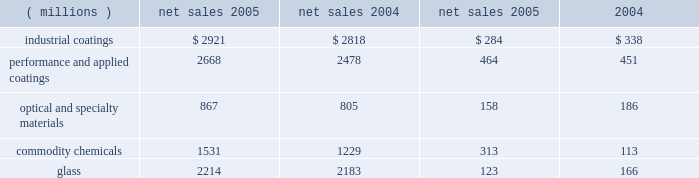Management 2019s discussion and analysis of increased volumes in our performance and applied coatings , optical and specialty materials and glass reportable business segments was offset by volume declines in the commodity chemicals reportable business segment .
The volume decline in the commodity chemicals reportable business segment was due in part to lost sales resulting from the impact of hurricane rita , as discussed below .
Cost of sales as a percentage of sales increased to 63.5% ( 63.5 % ) as compared to 63.1% ( 63.1 % ) in 2004 .
Inflation , including higher coatings raw material costs and higher energy costs in our commodity chemicals and glass reportable business segments increased our cost of sales .
Selling , general and administrative expense declined slightly as a percentage of sales to 17.4% ( 17.4 % ) despite increasing by $ 56 million in 2005 .
These costs increased primarily due to increased advertising in our optical products operating segment and higher expenses due to store expansions in our architectural coatings operating segment .
Interest expense declined $ 9 million in 2005 , reflecting the year over year reduction in the outstanding debt balance of $ 80 million .
Other charges increased $ 284 million in 2005 primarily due to pretax charges of $ 132 million related to the marvin legal settlement , net of $ 18 million in insurance recoveries , $ 61 million for the federal glass class action antitrust legal settlement , $ 34 million of direct costs related to the impact of hurricanes rita and katrina , $ 27 million for an asset impairment charge in our fine chemicals operating segment , $ 19 million for debt refinancing costs and an increase of $ 12 million for environmental remediation costs .
Net income and earnings per share 2013 assuming dilution for 2005 were $ 596 million and $ 3.49 respectively , compared to $ 683 million and $ 3.95 , respectively , for 2004 .
Net income in 2005 included aftertax charges of $ 117 million , or 68 cents a share , for legal settlements net of insurance ; $ 21 million , or 12 cents a share for direct costs related to the impact of hurricanes katrina and rita ; $ 17 million , or 10 cents a share related to an asset impairment charge related to our fine chemicals business ; and $ 12 million , or 7 cents a share , for debt refinancing costs .
The legal settlements net of insurance include aftertax charges of $ 80 million for the marvin legal settlement , net of insurance recoveries , and $ 37 million for the impact of the federal glass class action antitrust legal settlement .
Net income for 2005 and 2004 included an aftertax charge of $ 13 million , or 8 cents a share , and $ 19 million , or 11 cents a share , respectively , to reflect the net increase in the current value of the company 2019s obligation relating to asbestos claims under the ppg settlement arrangement .
Results of reportable business segments net sales segment income ( millions ) 2005 2004 2005 2004 industrial coatings $ 2921 $ 2818 $ 284 $ 338 performance and applied coatings 2668 2478 464 451 optical and specialty materials 867 805 158 186 .
Sales of industrial coatings increased $ 103 million or 4% ( 4 % ) in 2005 .
Sales increased 2% ( 2 % ) due to higher selling prices in our industrial and packaging coatings businesses and 2% ( 2 % ) due to the positive effects of foreign currency translation .
Volume was flat year over year as increased volume in automotive coatings was offset by lower volume in industrial and packaging coatings .
Segment income decreased $ 54 million in 2005 .
The decrease in segment income was due to the adverse impact of inflation , including raw materials costs increases of about $ 170 million , which more than offset the benefits of higher selling prices , improved sales margin mix , formula cost reductions , lower manufacturing costs and higher other income .
Performance and applied coatings sales increased $ 190 million or 8% ( 8 % ) in 2005 .
Sales increased 4% ( 4 % ) due to higher selling prices in all three operating segments , 3% ( 3 % ) due to increased volumes as increases in our aerospace and architectural coatings businesses exceeded volume declines in automotive refinish , and 1% ( 1 % ) due to the positive effects of foreign currency translation .
Performance and applied coatings segment income increased $ 13 million in 2005 .
Segment income increased due to the impact of increased sales volumes described above and higher other income , which combined to offset the negative impacts of higher overhead costs to support the growth in these businesses , particularly in the architectural coatings business , and higher manufacturing costs .
The impact of higher selling prices fully offset the adverse impact of inflation , including raw materials cost increases of about $ 75 million .
Optical and specialty materials sales increased $ 62 million or 8% ( 8 % ) .
Sales increased 8% ( 8 % ) due to higher sales volumes in our optical products and silica businesses , which offset lower sales volumes in our fine chemicals business .
Sales increased 1% ( 1 % ) due to an acquisition in our optical products business and decreased 1% ( 1 % ) due to lower pricing .
Segment income decreased $ 28 million .
The primary factor decreasing segment income was the $ 27 million impairment charge related to our fine chemicals business .
The impact of higher sales volumes described above was offset by higher inflation , including increased energy costs ; lower selling prices ; increased overhead costs in our optical products business to support growth 24 2006 ppg annual report and form 10-k 4282_txt .
What was the operating income return for 2005 in the performance and applied coatings segment? 
Computations: (464 / 2668)
Answer: 0.17391. 